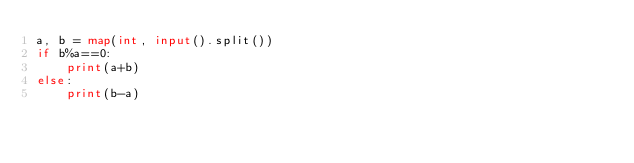Convert code to text. <code><loc_0><loc_0><loc_500><loc_500><_Python_>a, b = map(int, input().split())
if b%a==0:
    print(a+b)
else:
    print(b-a)</code> 